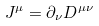Convert formula to latex. <formula><loc_0><loc_0><loc_500><loc_500>J ^ { \mu } = \partial _ { \nu } D ^ { \mu \nu }</formula> 